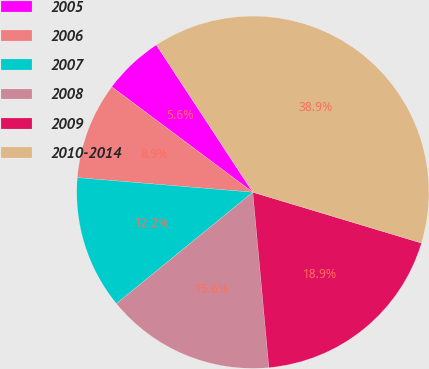<chart> <loc_0><loc_0><loc_500><loc_500><pie_chart><fcel>2005<fcel>2006<fcel>2007<fcel>2008<fcel>2009<fcel>2010-2014<nl><fcel>5.56%<fcel>8.89%<fcel>12.22%<fcel>15.56%<fcel>18.89%<fcel>38.89%<nl></chart> 